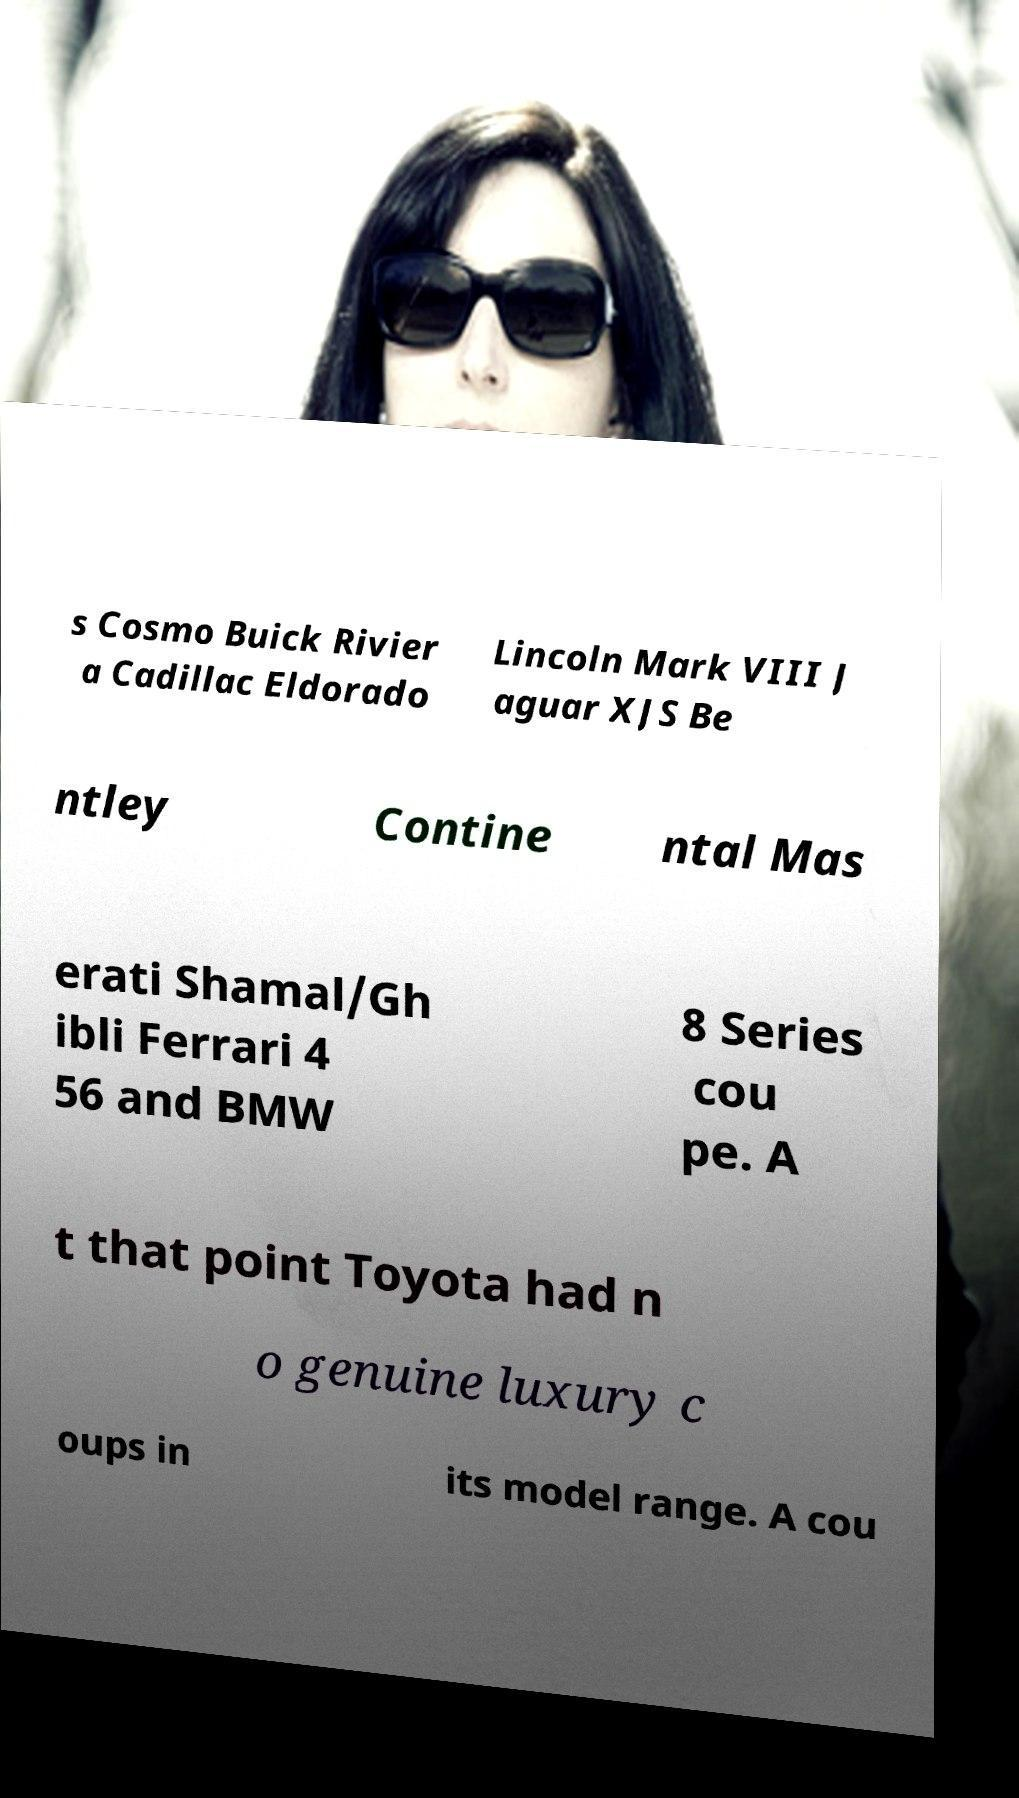Can you read and provide the text displayed in the image?This photo seems to have some interesting text. Can you extract and type it out for me? s Cosmo Buick Rivier a Cadillac Eldorado Lincoln Mark VIII J aguar XJS Be ntley Contine ntal Mas erati Shamal/Gh ibli Ferrari 4 56 and BMW 8 Series cou pe. A t that point Toyota had n o genuine luxury c oups in its model range. A cou 